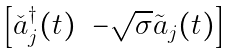<formula> <loc_0><loc_0><loc_500><loc_500>\begin{bmatrix} { \check { a } } _ { j } ^ { \dagger } ( t ) & - \sqrt { \sigma } { \tilde { a } } _ { j } ( t ) \end{bmatrix}</formula> 